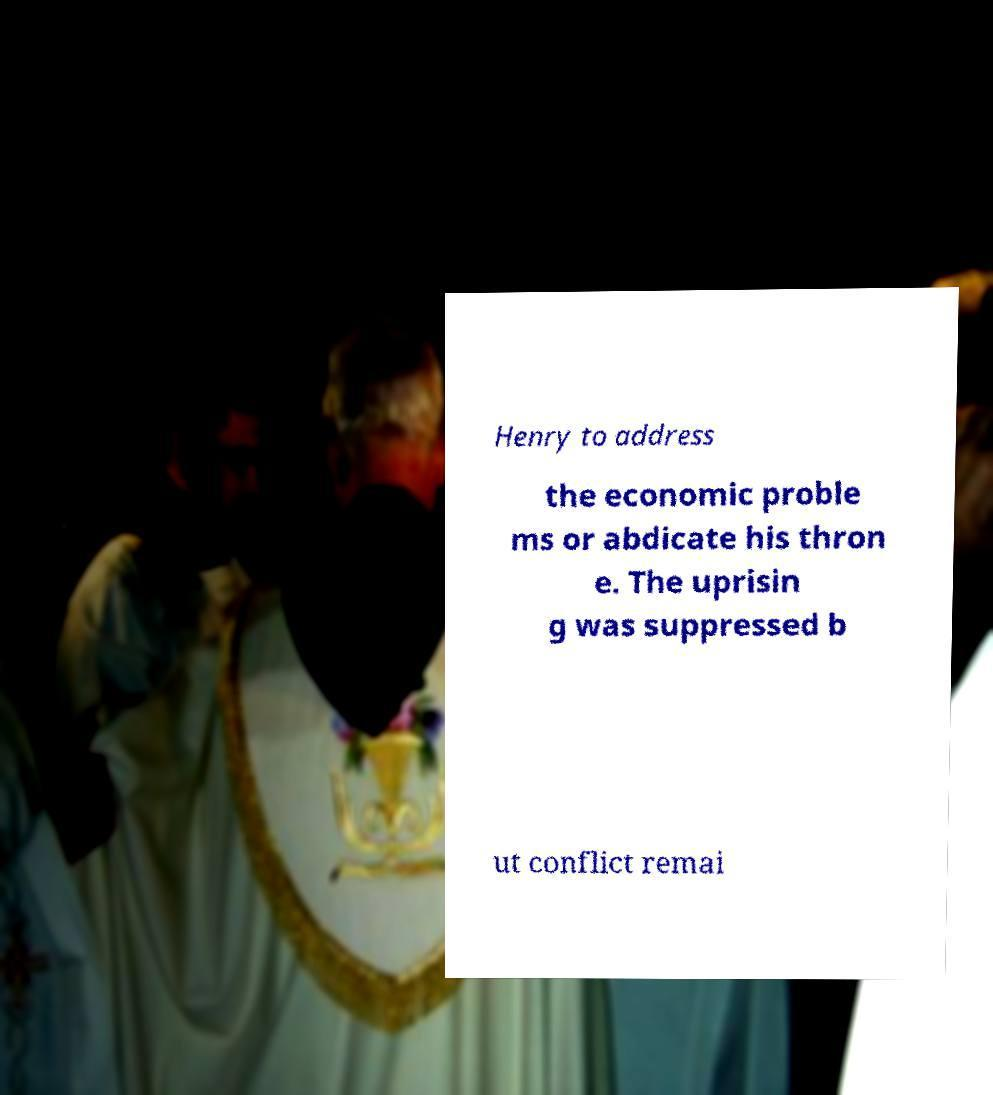There's text embedded in this image that I need extracted. Can you transcribe it verbatim? Henry to address the economic proble ms or abdicate his thron e. The uprisin g was suppressed b ut conflict remai 